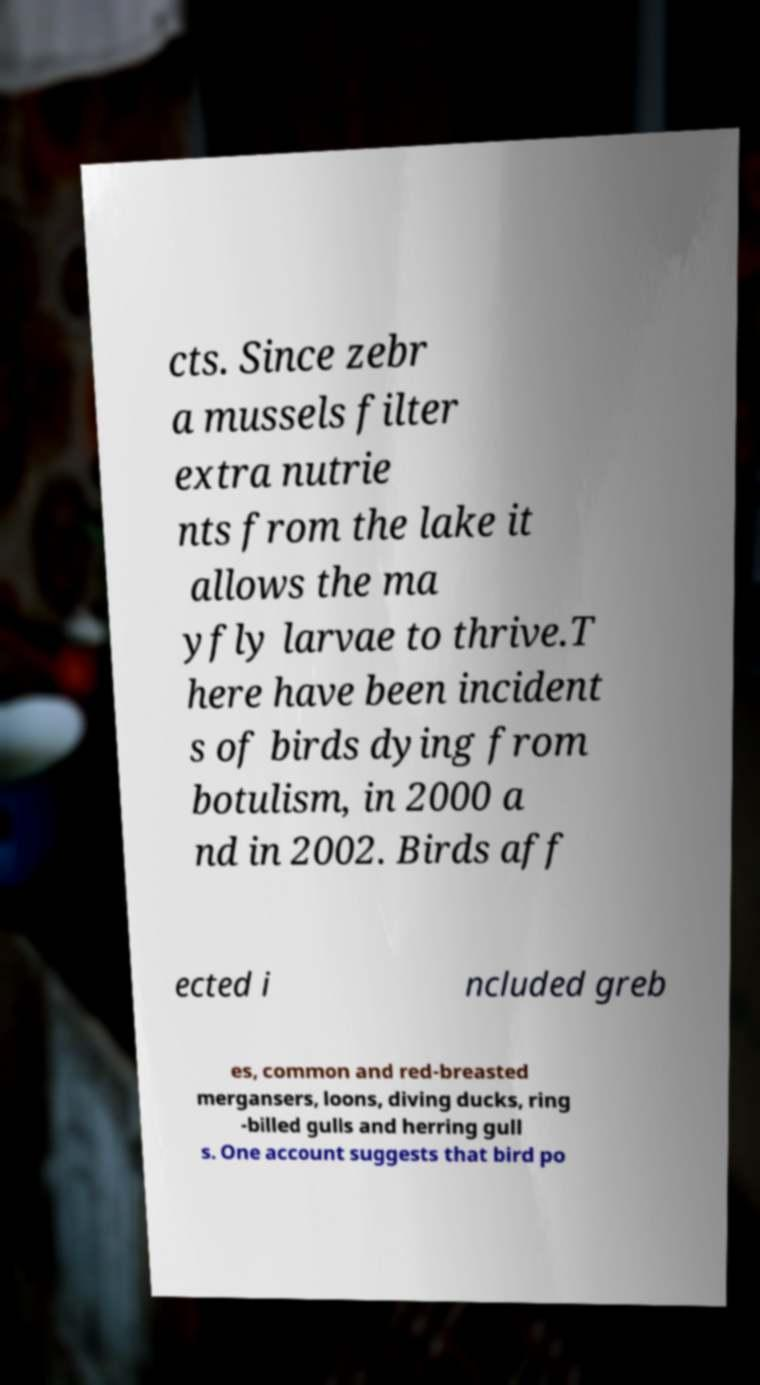What messages or text are displayed in this image? I need them in a readable, typed format. cts. Since zebr a mussels filter extra nutrie nts from the lake it allows the ma yfly larvae to thrive.T here have been incident s of birds dying from botulism, in 2000 a nd in 2002. Birds aff ected i ncluded greb es, common and red-breasted mergansers, loons, diving ducks, ring -billed gulls and herring gull s. One account suggests that bird po 